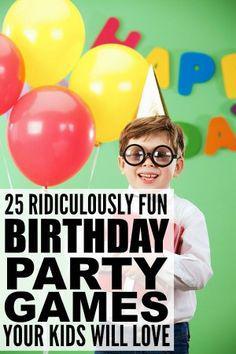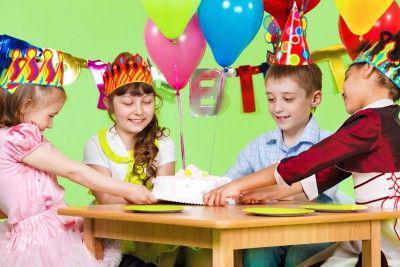The first image is the image on the left, the second image is the image on the right. Given the left and right images, does the statement "The right image has exactly eleven balloons" hold true? Answer yes or no. No. The first image is the image on the left, the second image is the image on the right. Examine the images to the left and right. Is the description "The left and right image contains a bushel of balloons with strings and at least two balloons are green," accurate? Answer yes or no. No. 